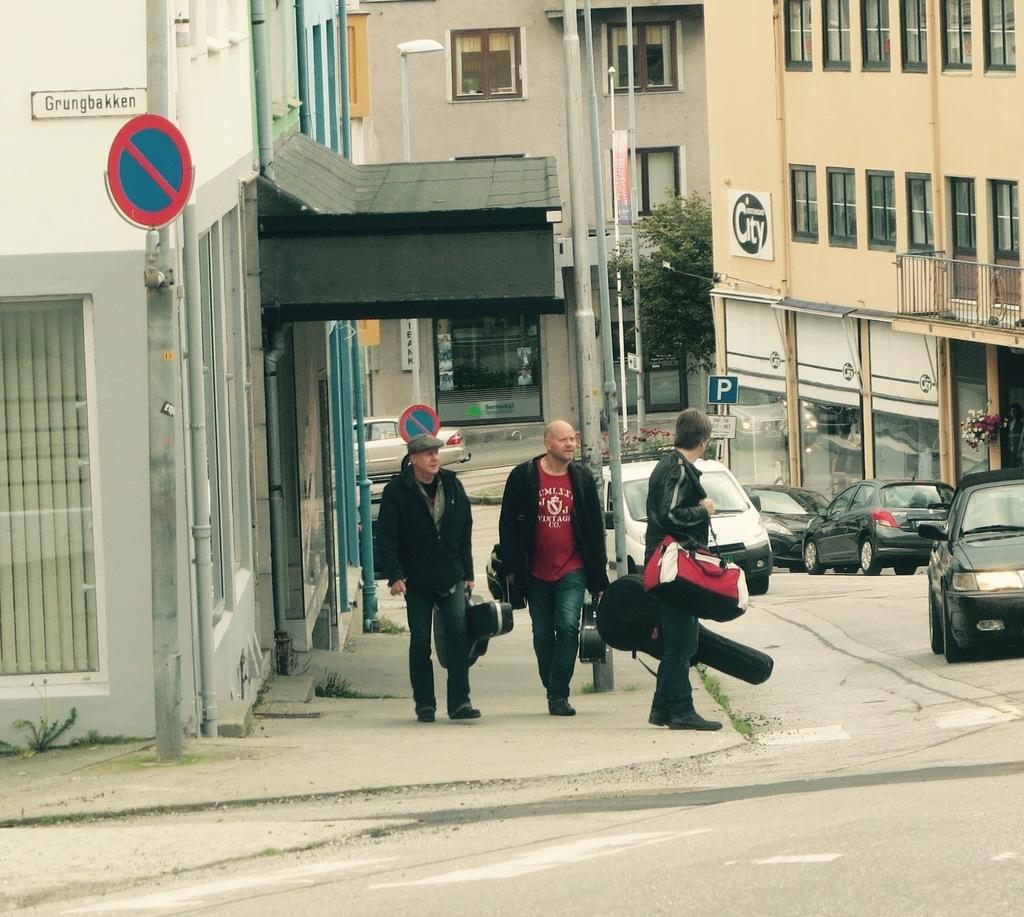<image>
Offer a succinct explanation of the picture presented. Some musicians are approaching the intersection of Grungbakken. 